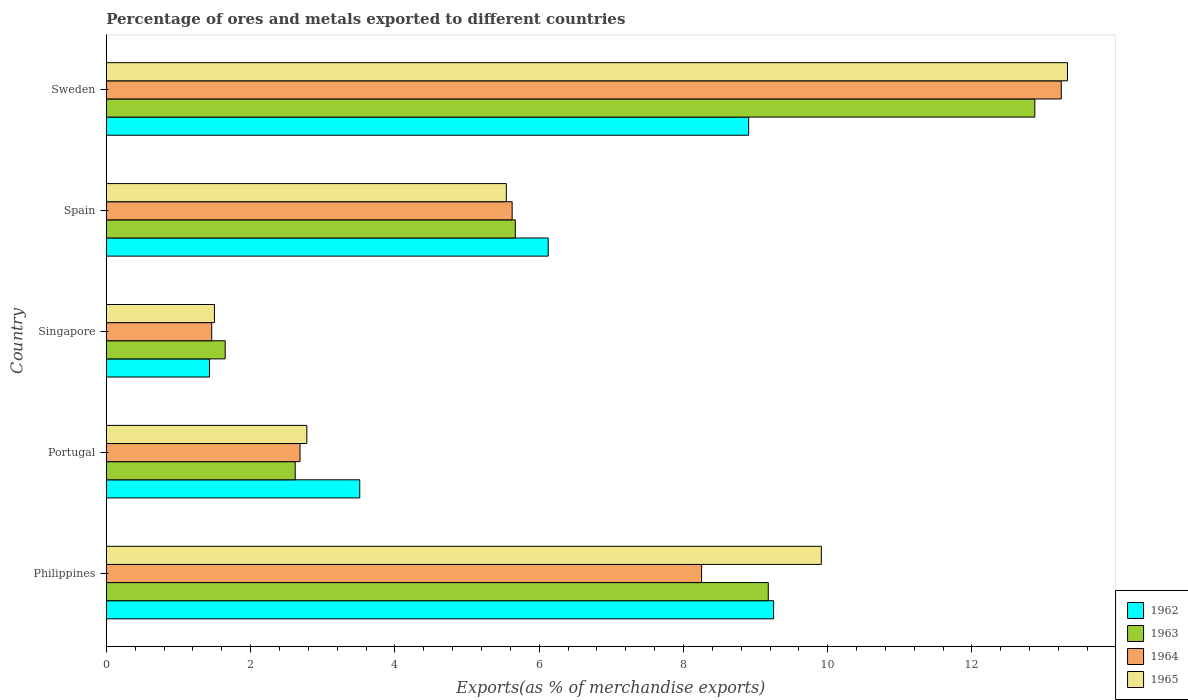How many groups of bars are there?
Your answer should be compact. 5. Are the number of bars on each tick of the Y-axis equal?
Your answer should be very brief. Yes. What is the label of the 3rd group of bars from the top?
Your response must be concise. Singapore. What is the percentage of exports to different countries in 1965 in Philippines?
Ensure brevity in your answer.  9.91. Across all countries, what is the maximum percentage of exports to different countries in 1963?
Offer a terse response. 12.87. Across all countries, what is the minimum percentage of exports to different countries in 1963?
Provide a succinct answer. 1.65. In which country was the percentage of exports to different countries in 1962 maximum?
Provide a succinct answer. Philippines. In which country was the percentage of exports to different countries in 1964 minimum?
Your answer should be compact. Singapore. What is the total percentage of exports to different countries in 1963 in the graph?
Keep it short and to the point. 31.98. What is the difference between the percentage of exports to different countries in 1965 in Portugal and that in Spain?
Give a very brief answer. -2.77. What is the difference between the percentage of exports to different countries in 1962 in Sweden and the percentage of exports to different countries in 1965 in Singapore?
Keep it short and to the point. 7.41. What is the average percentage of exports to different countries in 1963 per country?
Make the answer very short. 6.4. What is the difference between the percentage of exports to different countries in 1962 and percentage of exports to different countries in 1965 in Philippines?
Your answer should be very brief. -0.66. In how many countries, is the percentage of exports to different countries in 1963 greater than 4 %?
Your response must be concise. 3. What is the ratio of the percentage of exports to different countries in 1965 in Portugal to that in Spain?
Give a very brief answer. 0.5. What is the difference between the highest and the second highest percentage of exports to different countries in 1964?
Your answer should be very brief. 4.99. What is the difference between the highest and the lowest percentage of exports to different countries in 1964?
Provide a short and direct response. 11.78. In how many countries, is the percentage of exports to different countries in 1963 greater than the average percentage of exports to different countries in 1963 taken over all countries?
Your response must be concise. 2. Is the sum of the percentage of exports to different countries in 1963 in Singapore and Sweden greater than the maximum percentage of exports to different countries in 1965 across all countries?
Your response must be concise. Yes. What does the 2nd bar from the top in Sweden represents?
Make the answer very short. 1964. What does the 3rd bar from the bottom in Sweden represents?
Offer a very short reply. 1964. How many bars are there?
Keep it short and to the point. 20. Are all the bars in the graph horizontal?
Provide a succinct answer. Yes. How many countries are there in the graph?
Ensure brevity in your answer.  5. What is the difference between two consecutive major ticks on the X-axis?
Give a very brief answer. 2. Does the graph contain grids?
Your answer should be compact. No. Where does the legend appear in the graph?
Make the answer very short. Bottom right. How many legend labels are there?
Your response must be concise. 4. What is the title of the graph?
Offer a very short reply. Percentage of ores and metals exported to different countries. What is the label or title of the X-axis?
Your answer should be very brief. Exports(as % of merchandise exports). What is the Exports(as % of merchandise exports) of 1962 in Philippines?
Provide a succinct answer. 9.25. What is the Exports(as % of merchandise exports) in 1963 in Philippines?
Give a very brief answer. 9.18. What is the Exports(as % of merchandise exports) in 1964 in Philippines?
Ensure brevity in your answer.  8.25. What is the Exports(as % of merchandise exports) of 1965 in Philippines?
Your answer should be very brief. 9.91. What is the Exports(as % of merchandise exports) of 1962 in Portugal?
Provide a succinct answer. 3.51. What is the Exports(as % of merchandise exports) in 1963 in Portugal?
Give a very brief answer. 2.62. What is the Exports(as % of merchandise exports) in 1964 in Portugal?
Keep it short and to the point. 2.69. What is the Exports(as % of merchandise exports) in 1965 in Portugal?
Your answer should be compact. 2.78. What is the Exports(as % of merchandise exports) in 1962 in Singapore?
Offer a very short reply. 1.43. What is the Exports(as % of merchandise exports) in 1963 in Singapore?
Ensure brevity in your answer.  1.65. What is the Exports(as % of merchandise exports) in 1964 in Singapore?
Offer a very short reply. 1.46. What is the Exports(as % of merchandise exports) of 1965 in Singapore?
Your response must be concise. 1.5. What is the Exports(as % of merchandise exports) of 1962 in Spain?
Your answer should be compact. 6.13. What is the Exports(as % of merchandise exports) of 1963 in Spain?
Provide a succinct answer. 5.67. What is the Exports(as % of merchandise exports) of 1964 in Spain?
Offer a very short reply. 5.63. What is the Exports(as % of merchandise exports) in 1965 in Spain?
Provide a short and direct response. 5.55. What is the Exports(as % of merchandise exports) in 1962 in Sweden?
Make the answer very short. 8.9. What is the Exports(as % of merchandise exports) of 1963 in Sweden?
Make the answer very short. 12.87. What is the Exports(as % of merchandise exports) of 1964 in Sweden?
Your response must be concise. 13.24. What is the Exports(as % of merchandise exports) of 1965 in Sweden?
Provide a succinct answer. 13.32. Across all countries, what is the maximum Exports(as % of merchandise exports) of 1962?
Your answer should be compact. 9.25. Across all countries, what is the maximum Exports(as % of merchandise exports) of 1963?
Offer a very short reply. 12.87. Across all countries, what is the maximum Exports(as % of merchandise exports) of 1964?
Provide a succinct answer. 13.24. Across all countries, what is the maximum Exports(as % of merchandise exports) in 1965?
Keep it short and to the point. 13.32. Across all countries, what is the minimum Exports(as % of merchandise exports) of 1962?
Offer a very short reply. 1.43. Across all countries, what is the minimum Exports(as % of merchandise exports) of 1963?
Provide a succinct answer. 1.65. Across all countries, what is the minimum Exports(as % of merchandise exports) in 1964?
Your answer should be compact. 1.46. Across all countries, what is the minimum Exports(as % of merchandise exports) in 1965?
Offer a very short reply. 1.5. What is the total Exports(as % of merchandise exports) of 1962 in the graph?
Offer a very short reply. 29.22. What is the total Exports(as % of merchandise exports) of 1963 in the graph?
Provide a short and direct response. 31.98. What is the total Exports(as % of merchandise exports) in 1964 in the graph?
Provide a short and direct response. 31.26. What is the total Exports(as % of merchandise exports) of 1965 in the graph?
Offer a terse response. 33.06. What is the difference between the Exports(as % of merchandise exports) of 1962 in Philippines and that in Portugal?
Keep it short and to the point. 5.74. What is the difference between the Exports(as % of merchandise exports) of 1963 in Philippines and that in Portugal?
Ensure brevity in your answer.  6.56. What is the difference between the Exports(as % of merchandise exports) in 1964 in Philippines and that in Portugal?
Make the answer very short. 5.57. What is the difference between the Exports(as % of merchandise exports) of 1965 in Philippines and that in Portugal?
Make the answer very short. 7.13. What is the difference between the Exports(as % of merchandise exports) in 1962 in Philippines and that in Singapore?
Make the answer very short. 7.82. What is the difference between the Exports(as % of merchandise exports) of 1963 in Philippines and that in Singapore?
Your answer should be very brief. 7.53. What is the difference between the Exports(as % of merchandise exports) of 1964 in Philippines and that in Singapore?
Offer a terse response. 6.79. What is the difference between the Exports(as % of merchandise exports) in 1965 in Philippines and that in Singapore?
Ensure brevity in your answer.  8.41. What is the difference between the Exports(as % of merchandise exports) in 1962 in Philippines and that in Spain?
Ensure brevity in your answer.  3.12. What is the difference between the Exports(as % of merchandise exports) of 1963 in Philippines and that in Spain?
Offer a very short reply. 3.51. What is the difference between the Exports(as % of merchandise exports) of 1964 in Philippines and that in Spain?
Provide a succinct answer. 2.63. What is the difference between the Exports(as % of merchandise exports) in 1965 in Philippines and that in Spain?
Your answer should be compact. 4.37. What is the difference between the Exports(as % of merchandise exports) in 1962 in Philippines and that in Sweden?
Give a very brief answer. 0.35. What is the difference between the Exports(as % of merchandise exports) of 1963 in Philippines and that in Sweden?
Your answer should be very brief. -3.7. What is the difference between the Exports(as % of merchandise exports) of 1964 in Philippines and that in Sweden?
Your answer should be compact. -4.99. What is the difference between the Exports(as % of merchandise exports) in 1965 in Philippines and that in Sweden?
Keep it short and to the point. -3.41. What is the difference between the Exports(as % of merchandise exports) of 1962 in Portugal and that in Singapore?
Provide a short and direct response. 2.08. What is the difference between the Exports(as % of merchandise exports) in 1963 in Portugal and that in Singapore?
Keep it short and to the point. 0.97. What is the difference between the Exports(as % of merchandise exports) of 1964 in Portugal and that in Singapore?
Your answer should be very brief. 1.22. What is the difference between the Exports(as % of merchandise exports) of 1965 in Portugal and that in Singapore?
Offer a very short reply. 1.28. What is the difference between the Exports(as % of merchandise exports) in 1962 in Portugal and that in Spain?
Your response must be concise. -2.61. What is the difference between the Exports(as % of merchandise exports) of 1963 in Portugal and that in Spain?
Offer a very short reply. -3.05. What is the difference between the Exports(as % of merchandise exports) of 1964 in Portugal and that in Spain?
Provide a short and direct response. -2.94. What is the difference between the Exports(as % of merchandise exports) of 1965 in Portugal and that in Spain?
Your answer should be very brief. -2.77. What is the difference between the Exports(as % of merchandise exports) in 1962 in Portugal and that in Sweden?
Provide a succinct answer. -5.39. What is the difference between the Exports(as % of merchandise exports) of 1963 in Portugal and that in Sweden?
Give a very brief answer. -10.25. What is the difference between the Exports(as % of merchandise exports) in 1964 in Portugal and that in Sweden?
Your answer should be very brief. -10.55. What is the difference between the Exports(as % of merchandise exports) in 1965 in Portugal and that in Sweden?
Provide a short and direct response. -10.54. What is the difference between the Exports(as % of merchandise exports) in 1962 in Singapore and that in Spain?
Provide a succinct answer. -4.69. What is the difference between the Exports(as % of merchandise exports) in 1963 in Singapore and that in Spain?
Your answer should be compact. -4.02. What is the difference between the Exports(as % of merchandise exports) in 1964 in Singapore and that in Spain?
Your answer should be very brief. -4.16. What is the difference between the Exports(as % of merchandise exports) of 1965 in Singapore and that in Spain?
Offer a terse response. -4.05. What is the difference between the Exports(as % of merchandise exports) in 1962 in Singapore and that in Sweden?
Offer a very short reply. -7.47. What is the difference between the Exports(as % of merchandise exports) of 1963 in Singapore and that in Sweden?
Offer a terse response. -11.22. What is the difference between the Exports(as % of merchandise exports) of 1964 in Singapore and that in Sweden?
Your answer should be compact. -11.78. What is the difference between the Exports(as % of merchandise exports) in 1965 in Singapore and that in Sweden?
Offer a very short reply. -11.83. What is the difference between the Exports(as % of merchandise exports) in 1962 in Spain and that in Sweden?
Provide a succinct answer. -2.78. What is the difference between the Exports(as % of merchandise exports) of 1963 in Spain and that in Sweden?
Your answer should be very brief. -7.2. What is the difference between the Exports(as % of merchandise exports) of 1964 in Spain and that in Sweden?
Your answer should be very brief. -7.61. What is the difference between the Exports(as % of merchandise exports) of 1965 in Spain and that in Sweden?
Keep it short and to the point. -7.78. What is the difference between the Exports(as % of merchandise exports) of 1962 in Philippines and the Exports(as % of merchandise exports) of 1963 in Portugal?
Offer a terse response. 6.63. What is the difference between the Exports(as % of merchandise exports) in 1962 in Philippines and the Exports(as % of merchandise exports) in 1964 in Portugal?
Provide a succinct answer. 6.56. What is the difference between the Exports(as % of merchandise exports) of 1962 in Philippines and the Exports(as % of merchandise exports) of 1965 in Portugal?
Make the answer very short. 6.47. What is the difference between the Exports(as % of merchandise exports) of 1963 in Philippines and the Exports(as % of merchandise exports) of 1964 in Portugal?
Provide a short and direct response. 6.49. What is the difference between the Exports(as % of merchandise exports) in 1963 in Philippines and the Exports(as % of merchandise exports) in 1965 in Portugal?
Provide a succinct answer. 6.4. What is the difference between the Exports(as % of merchandise exports) of 1964 in Philippines and the Exports(as % of merchandise exports) of 1965 in Portugal?
Your answer should be compact. 5.47. What is the difference between the Exports(as % of merchandise exports) in 1962 in Philippines and the Exports(as % of merchandise exports) in 1963 in Singapore?
Your answer should be compact. 7.6. What is the difference between the Exports(as % of merchandise exports) in 1962 in Philippines and the Exports(as % of merchandise exports) in 1964 in Singapore?
Make the answer very short. 7.79. What is the difference between the Exports(as % of merchandise exports) in 1962 in Philippines and the Exports(as % of merchandise exports) in 1965 in Singapore?
Provide a succinct answer. 7.75. What is the difference between the Exports(as % of merchandise exports) in 1963 in Philippines and the Exports(as % of merchandise exports) in 1964 in Singapore?
Make the answer very short. 7.72. What is the difference between the Exports(as % of merchandise exports) of 1963 in Philippines and the Exports(as % of merchandise exports) of 1965 in Singapore?
Provide a short and direct response. 7.68. What is the difference between the Exports(as % of merchandise exports) of 1964 in Philippines and the Exports(as % of merchandise exports) of 1965 in Singapore?
Offer a very short reply. 6.75. What is the difference between the Exports(as % of merchandise exports) of 1962 in Philippines and the Exports(as % of merchandise exports) of 1963 in Spain?
Make the answer very short. 3.58. What is the difference between the Exports(as % of merchandise exports) in 1962 in Philippines and the Exports(as % of merchandise exports) in 1964 in Spain?
Make the answer very short. 3.62. What is the difference between the Exports(as % of merchandise exports) of 1962 in Philippines and the Exports(as % of merchandise exports) of 1965 in Spain?
Your answer should be compact. 3.7. What is the difference between the Exports(as % of merchandise exports) of 1963 in Philippines and the Exports(as % of merchandise exports) of 1964 in Spain?
Provide a short and direct response. 3.55. What is the difference between the Exports(as % of merchandise exports) in 1963 in Philippines and the Exports(as % of merchandise exports) in 1965 in Spain?
Make the answer very short. 3.63. What is the difference between the Exports(as % of merchandise exports) in 1964 in Philippines and the Exports(as % of merchandise exports) in 1965 in Spain?
Give a very brief answer. 2.71. What is the difference between the Exports(as % of merchandise exports) of 1962 in Philippines and the Exports(as % of merchandise exports) of 1963 in Sweden?
Your answer should be compact. -3.62. What is the difference between the Exports(as % of merchandise exports) in 1962 in Philippines and the Exports(as % of merchandise exports) in 1964 in Sweden?
Provide a short and direct response. -3.99. What is the difference between the Exports(as % of merchandise exports) of 1962 in Philippines and the Exports(as % of merchandise exports) of 1965 in Sweden?
Offer a very short reply. -4.07. What is the difference between the Exports(as % of merchandise exports) of 1963 in Philippines and the Exports(as % of merchandise exports) of 1964 in Sweden?
Keep it short and to the point. -4.06. What is the difference between the Exports(as % of merchandise exports) of 1963 in Philippines and the Exports(as % of merchandise exports) of 1965 in Sweden?
Provide a short and direct response. -4.15. What is the difference between the Exports(as % of merchandise exports) in 1964 in Philippines and the Exports(as % of merchandise exports) in 1965 in Sweden?
Your answer should be very brief. -5.07. What is the difference between the Exports(as % of merchandise exports) in 1962 in Portugal and the Exports(as % of merchandise exports) in 1963 in Singapore?
Make the answer very short. 1.87. What is the difference between the Exports(as % of merchandise exports) in 1962 in Portugal and the Exports(as % of merchandise exports) in 1964 in Singapore?
Keep it short and to the point. 2.05. What is the difference between the Exports(as % of merchandise exports) in 1962 in Portugal and the Exports(as % of merchandise exports) in 1965 in Singapore?
Give a very brief answer. 2.01. What is the difference between the Exports(as % of merchandise exports) in 1963 in Portugal and the Exports(as % of merchandise exports) in 1964 in Singapore?
Offer a very short reply. 1.16. What is the difference between the Exports(as % of merchandise exports) in 1963 in Portugal and the Exports(as % of merchandise exports) in 1965 in Singapore?
Provide a short and direct response. 1.12. What is the difference between the Exports(as % of merchandise exports) of 1964 in Portugal and the Exports(as % of merchandise exports) of 1965 in Singapore?
Give a very brief answer. 1.19. What is the difference between the Exports(as % of merchandise exports) in 1962 in Portugal and the Exports(as % of merchandise exports) in 1963 in Spain?
Keep it short and to the point. -2.16. What is the difference between the Exports(as % of merchandise exports) of 1962 in Portugal and the Exports(as % of merchandise exports) of 1964 in Spain?
Your answer should be compact. -2.11. What is the difference between the Exports(as % of merchandise exports) of 1962 in Portugal and the Exports(as % of merchandise exports) of 1965 in Spain?
Your answer should be very brief. -2.03. What is the difference between the Exports(as % of merchandise exports) of 1963 in Portugal and the Exports(as % of merchandise exports) of 1964 in Spain?
Keep it short and to the point. -3.01. What is the difference between the Exports(as % of merchandise exports) in 1963 in Portugal and the Exports(as % of merchandise exports) in 1965 in Spain?
Ensure brevity in your answer.  -2.93. What is the difference between the Exports(as % of merchandise exports) of 1964 in Portugal and the Exports(as % of merchandise exports) of 1965 in Spain?
Provide a succinct answer. -2.86. What is the difference between the Exports(as % of merchandise exports) in 1962 in Portugal and the Exports(as % of merchandise exports) in 1963 in Sweden?
Your answer should be very brief. -9.36. What is the difference between the Exports(as % of merchandise exports) in 1962 in Portugal and the Exports(as % of merchandise exports) in 1964 in Sweden?
Make the answer very short. -9.72. What is the difference between the Exports(as % of merchandise exports) in 1962 in Portugal and the Exports(as % of merchandise exports) in 1965 in Sweden?
Your answer should be compact. -9.81. What is the difference between the Exports(as % of merchandise exports) of 1963 in Portugal and the Exports(as % of merchandise exports) of 1964 in Sweden?
Offer a terse response. -10.62. What is the difference between the Exports(as % of merchandise exports) of 1963 in Portugal and the Exports(as % of merchandise exports) of 1965 in Sweden?
Your answer should be very brief. -10.71. What is the difference between the Exports(as % of merchandise exports) in 1964 in Portugal and the Exports(as % of merchandise exports) in 1965 in Sweden?
Keep it short and to the point. -10.64. What is the difference between the Exports(as % of merchandise exports) in 1962 in Singapore and the Exports(as % of merchandise exports) in 1963 in Spain?
Give a very brief answer. -4.24. What is the difference between the Exports(as % of merchandise exports) of 1962 in Singapore and the Exports(as % of merchandise exports) of 1964 in Spain?
Your answer should be very brief. -4.2. What is the difference between the Exports(as % of merchandise exports) in 1962 in Singapore and the Exports(as % of merchandise exports) in 1965 in Spain?
Keep it short and to the point. -4.11. What is the difference between the Exports(as % of merchandise exports) in 1963 in Singapore and the Exports(as % of merchandise exports) in 1964 in Spain?
Offer a terse response. -3.98. What is the difference between the Exports(as % of merchandise exports) of 1963 in Singapore and the Exports(as % of merchandise exports) of 1965 in Spain?
Ensure brevity in your answer.  -3.9. What is the difference between the Exports(as % of merchandise exports) in 1964 in Singapore and the Exports(as % of merchandise exports) in 1965 in Spain?
Keep it short and to the point. -4.08. What is the difference between the Exports(as % of merchandise exports) in 1962 in Singapore and the Exports(as % of merchandise exports) in 1963 in Sweden?
Ensure brevity in your answer.  -11.44. What is the difference between the Exports(as % of merchandise exports) in 1962 in Singapore and the Exports(as % of merchandise exports) in 1964 in Sweden?
Keep it short and to the point. -11.81. What is the difference between the Exports(as % of merchandise exports) of 1962 in Singapore and the Exports(as % of merchandise exports) of 1965 in Sweden?
Offer a terse response. -11.89. What is the difference between the Exports(as % of merchandise exports) in 1963 in Singapore and the Exports(as % of merchandise exports) in 1964 in Sweden?
Ensure brevity in your answer.  -11.59. What is the difference between the Exports(as % of merchandise exports) of 1963 in Singapore and the Exports(as % of merchandise exports) of 1965 in Sweden?
Offer a very short reply. -11.68. What is the difference between the Exports(as % of merchandise exports) of 1964 in Singapore and the Exports(as % of merchandise exports) of 1965 in Sweden?
Your response must be concise. -11.86. What is the difference between the Exports(as % of merchandise exports) in 1962 in Spain and the Exports(as % of merchandise exports) in 1963 in Sweden?
Provide a succinct answer. -6.75. What is the difference between the Exports(as % of merchandise exports) in 1962 in Spain and the Exports(as % of merchandise exports) in 1964 in Sweden?
Offer a terse response. -7.11. What is the difference between the Exports(as % of merchandise exports) in 1962 in Spain and the Exports(as % of merchandise exports) in 1965 in Sweden?
Offer a very short reply. -7.2. What is the difference between the Exports(as % of merchandise exports) in 1963 in Spain and the Exports(as % of merchandise exports) in 1964 in Sweden?
Your answer should be very brief. -7.57. What is the difference between the Exports(as % of merchandise exports) of 1963 in Spain and the Exports(as % of merchandise exports) of 1965 in Sweden?
Provide a short and direct response. -7.65. What is the difference between the Exports(as % of merchandise exports) in 1964 in Spain and the Exports(as % of merchandise exports) in 1965 in Sweden?
Provide a short and direct response. -7.7. What is the average Exports(as % of merchandise exports) of 1962 per country?
Your answer should be compact. 5.84. What is the average Exports(as % of merchandise exports) in 1963 per country?
Provide a succinct answer. 6.4. What is the average Exports(as % of merchandise exports) of 1964 per country?
Make the answer very short. 6.25. What is the average Exports(as % of merchandise exports) of 1965 per country?
Your answer should be very brief. 6.61. What is the difference between the Exports(as % of merchandise exports) of 1962 and Exports(as % of merchandise exports) of 1963 in Philippines?
Your answer should be compact. 0.07. What is the difference between the Exports(as % of merchandise exports) in 1962 and Exports(as % of merchandise exports) in 1965 in Philippines?
Provide a short and direct response. -0.66. What is the difference between the Exports(as % of merchandise exports) in 1963 and Exports(as % of merchandise exports) in 1964 in Philippines?
Your response must be concise. 0.92. What is the difference between the Exports(as % of merchandise exports) of 1963 and Exports(as % of merchandise exports) of 1965 in Philippines?
Your response must be concise. -0.74. What is the difference between the Exports(as % of merchandise exports) in 1964 and Exports(as % of merchandise exports) in 1965 in Philippines?
Your answer should be compact. -1.66. What is the difference between the Exports(as % of merchandise exports) of 1962 and Exports(as % of merchandise exports) of 1963 in Portugal?
Offer a terse response. 0.89. What is the difference between the Exports(as % of merchandise exports) in 1962 and Exports(as % of merchandise exports) in 1964 in Portugal?
Your answer should be compact. 0.83. What is the difference between the Exports(as % of merchandise exports) of 1962 and Exports(as % of merchandise exports) of 1965 in Portugal?
Provide a succinct answer. 0.73. What is the difference between the Exports(as % of merchandise exports) in 1963 and Exports(as % of merchandise exports) in 1964 in Portugal?
Ensure brevity in your answer.  -0.07. What is the difference between the Exports(as % of merchandise exports) in 1963 and Exports(as % of merchandise exports) in 1965 in Portugal?
Your response must be concise. -0.16. What is the difference between the Exports(as % of merchandise exports) in 1964 and Exports(as % of merchandise exports) in 1965 in Portugal?
Your answer should be compact. -0.09. What is the difference between the Exports(as % of merchandise exports) of 1962 and Exports(as % of merchandise exports) of 1963 in Singapore?
Your answer should be very brief. -0.22. What is the difference between the Exports(as % of merchandise exports) of 1962 and Exports(as % of merchandise exports) of 1964 in Singapore?
Your answer should be very brief. -0.03. What is the difference between the Exports(as % of merchandise exports) of 1962 and Exports(as % of merchandise exports) of 1965 in Singapore?
Provide a short and direct response. -0.07. What is the difference between the Exports(as % of merchandise exports) of 1963 and Exports(as % of merchandise exports) of 1964 in Singapore?
Offer a terse response. 0.19. What is the difference between the Exports(as % of merchandise exports) of 1963 and Exports(as % of merchandise exports) of 1965 in Singapore?
Make the answer very short. 0.15. What is the difference between the Exports(as % of merchandise exports) in 1964 and Exports(as % of merchandise exports) in 1965 in Singapore?
Provide a short and direct response. -0.04. What is the difference between the Exports(as % of merchandise exports) in 1962 and Exports(as % of merchandise exports) in 1963 in Spain?
Provide a succinct answer. 0.46. What is the difference between the Exports(as % of merchandise exports) in 1962 and Exports(as % of merchandise exports) in 1964 in Spain?
Your response must be concise. 0.5. What is the difference between the Exports(as % of merchandise exports) of 1962 and Exports(as % of merchandise exports) of 1965 in Spain?
Your answer should be compact. 0.58. What is the difference between the Exports(as % of merchandise exports) of 1963 and Exports(as % of merchandise exports) of 1964 in Spain?
Offer a very short reply. 0.04. What is the difference between the Exports(as % of merchandise exports) in 1963 and Exports(as % of merchandise exports) in 1965 in Spain?
Your answer should be compact. 0.12. What is the difference between the Exports(as % of merchandise exports) in 1964 and Exports(as % of merchandise exports) in 1965 in Spain?
Offer a terse response. 0.08. What is the difference between the Exports(as % of merchandise exports) in 1962 and Exports(as % of merchandise exports) in 1963 in Sweden?
Make the answer very short. -3.97. What is the difference between the Exports(as % of merchandise exports) of 1962 and Exports(as % of merchandise exports) of 1964 in Sweden?
Ensure brevity in your answer.  -4.33. What is the difference between the Exports(as % of merchandise exports) in 1962 and Exports(as % of merchandise exports) in 1965 in Sweden?
Provide a succinct answer. -4.42. What is the difference between the Exports(as % of merchandise exports) of 1963 and Exports(as % of merchandise exports) of 1964 in Sweden?
Ensure brevity in your answer.  -0.37. What is the difference between the Exports(as % of merchandise exports) in 1963 and Exports(as % of merchandise exports) in 1965 in Sweden?
Offer a terse response. -0.45. What is the difference between the Exports(as % of merchandise exports) of 1964 and Exports(as % of merchandise exports) of 1965 in Sweden?
Your response must be concise. -0.09. What is the ratio of the Exports(as % of merchandise exports) in 1962 in Philippines to that in Portugal?
Give a very brief answer. 2.63. What is the ratio of the Exports(as % of merchandise exports) of 1963 in Philippines to that in Portugal?
Make the answer very short. 3.5. What is the ratio of the Exports(as % of merchandise exports) in 1964 in Philippines to that in Portugal?
Offer a very short reply. 3.07. What is the ratio of the Exports(as % of merchandise exports) of 1965 in Philippines to that in Portugal?
Give a very brief answer. 3.57. What is the ratio of the Exports(as % of merchandise exports) of 1962 in Philippines to that in Singapore?
Offer a very short reply. 6.47. What is the ratio of the Exports(as % of merchandise exports) in 1963 in Philippines to that in Singapore?
Your answer should be very brief. 5.57. What is the ratio of the Exports(as % of merchandise exports) of 1964 in Philippines to that in Singapore?
Ensure brevity in your answer.  5.65. What is the ratio of the Exports(as % of merchandise exports) in 1965 in Philippines to that in Singapore?
Your answer should be very brief. 6.61. What is the ratio of the Exports(as % of merchandise exports) of 1962 in Philippines to that in Spain?
Your answer should be compact. 1.51. What is the ratio of the Exports(as % of merchandise exports) in 1963 in Philippines to that in Spain?
Offer a terse response. 1.62. What is the ratio of the Exports(as % of merchandise exports) of 1964 in Philippines to that in Spain?
Make the answer very short. 1.47. What is the ratio of the Exports(as % of merchandise exports) in 1965 in Philippines to that in Spain?
Give a very brief answer. 1.79. What is the ratio of the Exports(as % of merchandise exports) in 1962 in Philippines to that in Sweden?
Your answer should be very brief. 1.04. What is the ratio of the Exports(as % of merchandise exports) of 1963 in Philippines to that in Sweden?
Your answer should be very brief. 0.71. What is the ratio of the Exports(as % of merchandise exports) in 1964 in Philippines to that in Sweden?
Your answer should be very brief. 0.62. What is the ratio of the Exports(as % of merchandise exports) of 1965 in Philippines to that in Sweden?
Provide a succinct answer. 0.74. What is the ratio of the Exports(as % of merchandise exports) of 1962 in Portugal to that in Singapore?
Provide a short and direct response. 2.46. What is the ratio of the Exports(as % of merchandise exports) in 1963 in Portugal to that in Singapore?
Your response must be concise. 1.59. What is the ratio of the Exports(as % of merchandise exports) of 1964 in Portugal to that in Singapore?
Make the answer very short. 1.84. What is the ratio of the Exports(as % of merchandise exports) of 1965 in Portugal to that in Singapore?
Provide a succinct answer. 1.85. What is the ratio of the Exports(as % of merchandise exports) in 1962 in Portugal to that in Spain?
Keep it short and to the point. 0.57. What is the ratio of the Exports(as % of merchandise exports) of 1963 in Portugal to that in Spain?
Your answer should be compact. 0.46. What is the ratio of the Exports(as % of merchandise exports) in 1964 in Portugal to that in Spain?
Provide a short and direct response. 0.48. What is the ratio of the Exports(as % of merchandise exports) in 1965 in Portugal to that in Spain?
Keep it short and to the point. 0.5. What is the ratio of the Exports(as % of merchandise exports) of 1962 in Portugal to that in Sweden?
Make the answer very short. 0.39. What is the ratio of the Exports(as % of merchandise exports) in 1963 in Portugal to that in Sweden?
Your answer should be very brief. 0.2. What is the ratio of the Exports(as % of merchandise exports) of 1964 in Portugal to that in Sweden?
Ensure brevity in your answer.  0.2. What is the ratio of the Exports(as % of merchandise exports) in 1965 in Portugal to that in Sweden?
Your response must be concise. 0.21. What is the ratio of the Exports(as % of merchandise exports) in 1962 in Singapore to that in Spain?
Give a very brief answer. 0.23. What is the ratio of the Exports(as % of merchandise exports) of 1963 in Singapore to that in Spain?
Your answer should be very brief. 0.29. What is the ratio of the Exports(as % of merchandise exports) in 1964 in Singapore to that in Spain?
Ensure brevity in your answer.  0.26. What is the ratio of the Exports(as % of merchandise exports) of 1965 in Singapore to that in Spain?
Give a very brief answer. 0.27. What is the ratio of the Exports(as % of merchandise exports) in 1962 in Singapore to that in Sweden?
Your answer should be very brief. 0.16. What is the ratio of the Exports(as % of merchandise exports) of 1963 in Singapore to that in Sweden?
Offer a very short reply. 0.13. What is the ratio of the Exports(as % of merchandise exports) of 1964 in Singapore to that in Sweden?
Provide a succinct answer. 0.11. What is the ratio of the Exports(as % of merchandise exports) in 1965 in Singapore to that in Sweden?
Provide a short and direct response. 0.11. What is the ratio of the Exports(as % of merchandise exports) in 1962 in Spain to that in Sweden?
Offer a very short reply. 0.69. What is the ratio of the Exports(as % of merchandise exports) in 1963 in Spain to that in Sweden?
Provide a short and direct response. 0.44. What is the ratio of the Exports(as % of merchandise exports) in 1964 in Spain to that in Sweden?
Offer a very short reply. 0.42. What is the ratio of the Exports(as % of merchandise exports) in 1965 in Spain to that in Sweden?
Your response must be concise. 0.42. What is the difference between the highest and the second highest Exports(as % of merchandise exports) in 1962?
Your answer should be very brief. 0.35. What is the difference between the highest and the second highest Exports(as % of merchandise exports) of 1963?
Offer a very short reply. 3.7. What is the difference between the highest and the second highest Exports(as % of merchandise exports) of 1964?
Make the answer very short. 4.99. What is the difference between the highest and the second highest Exports(as % of merchandise exports) in 1965?
Give a very brief answer. 3.41. What is the difference between the highest and the lowest Exports(as % of merchandise exports) of 1962?
Your answer should be very brief. 7.82. What is the difference between the highest and the lowest Exports(as % of merchandise exports) in 1963?
Offer a very short reply. 11.22. What is the difference between the highest and the lowest Exports(as % of merchandise exports) in 1964?
Your answer should be very brief. 11.78. What is the difference between the highest and the lowest Exports(as % of merchandise exports) in 1965?
Your answer should be very brief. 11.83. 